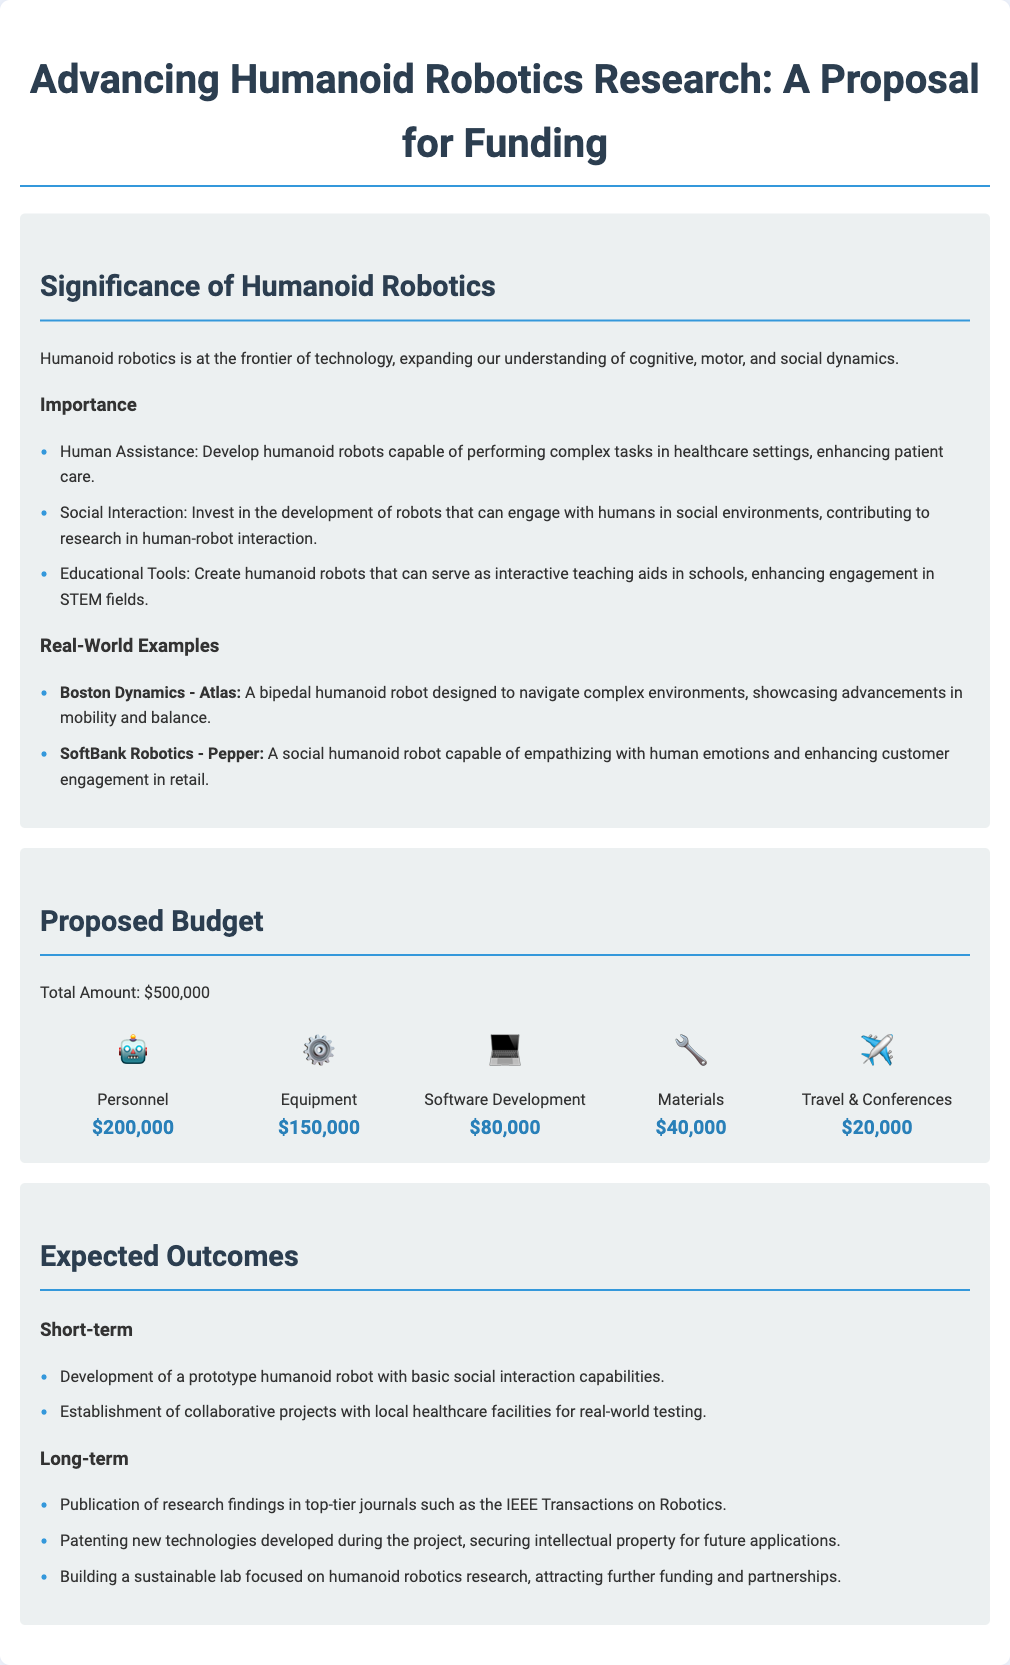What is the total proposed budget? The total proposed budget is explicitly stated in the document, which is $500,000.
Answer: $500,000 What are the short-term expected outcomes? The short-term expected outcomes include the development of a prototype robot and the establishment of collaborative projects, directly listed in the document.
Answer: Prototype humanoid robot with basic social interaction capabilities What percentage of the budget is allocated to personnel? Personnel budget is $200,000 out of $500,000, calculated as (200,000/500,000) * 100, which reflects budget allocation.
Answer: 40% Name one real-world example of humanoid robotics mentioned. The document provides specific examples of humanoid robots, including Boston Dynamics' Atlas.
Answer: Boston Dynamics - Atlas What is one long-term expected outcome? The long-term expected outcomes include multiple items, with one specified outcome being the publication of research findings in notable journals.
Answer: Publication of research findings in top-tier journals What category receives the highest budget allocation? The budget breakdown indicates the largest portion is allocated to personnel, which is the first item in the budget chart.
Answer: Personnel 